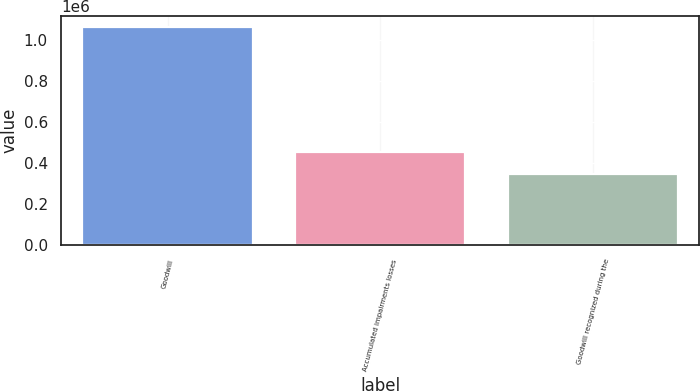Convert chart. <chart><loc_0><loc_0><loc_500><loc_500><bar_chart><fcel>Goodwill<fcel>Accumulated impairments losses<fcel>Goodwill recognized during the<nl><fcel>1.06519e+06<fcel>452441<fcel>345905<nl></chart> 